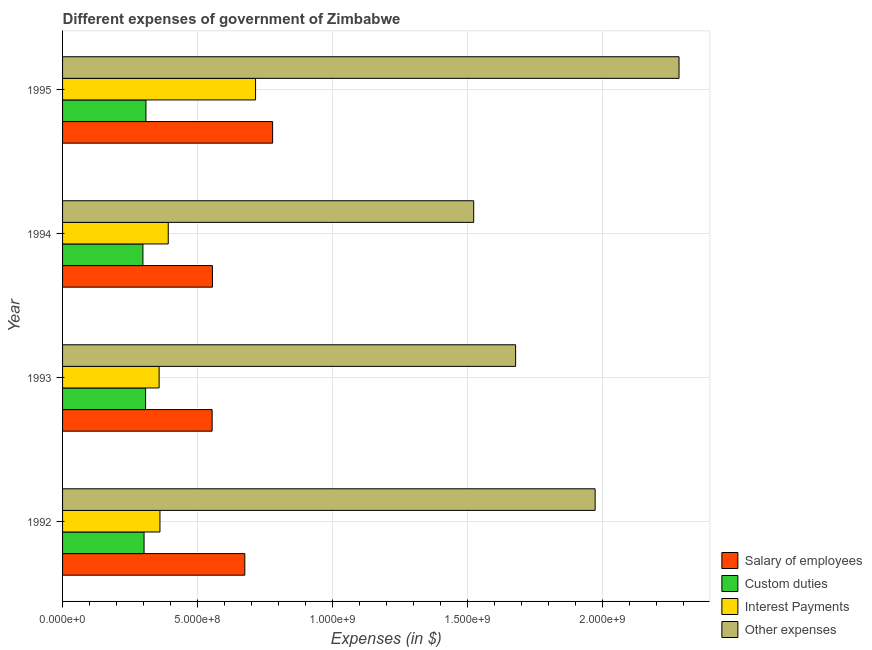Are the number of bars on each tick of the Y-axis equal?
Offer a terse response. Yes. How many bars are there on the 2nd tick from the bottom?
Make the answer very short. 4. What is the label of the 4th group of bars from the top?
Your answer should be very brief. 1992. In how many cases, is the number of bars for a given year not equal to the number of legend labels?
Keep it short and to the point. 0. What is the amount spent on salary of employees in 1994?
Your answer should be very brief. 5.55e+08. Across all years, what is the maximum amount spent on custom duties?
Make the answer very short. 3.09e+08. Across all years, what is the minimum amount spent on other expenses?
Your response must be concise. 1.52e+09. In which year was the amount spent on custom duties maximum?
Offer a very short reply. 1995. What is the total amount spent on salary of employees in the graph?
Provide a short and direct response. 2.56e+09. What is the difference between the amount spent on custom duties in 1994 and that in 1995?
Ensure brevity in your answer.  -1.12e+07. What is the difference between the amount spent on salary of employees in 1994 and the amount spent on interest payments in 1992?
Keep it short and to the point. 1.94e+08. What is the average amount spent on other expenses per year?
Provide a succinct answer. 1.86e+09. In the year 1995, what is the difference between the amount spent on interest payments and amount spent on other expenses?
Your answer should be compact. -1.57e+09. What is the ratio of the amount spent on salary of employees in 1994 to that in 1995?
Offer a terse response. 0.71. Is the amount spent on salary of employees in 1992 less than that in 1994?
Your answer should be compact. No. Is the difference between the amount spent on interest payments in 1993 and 1995 greater than the difference between the amount spent on salary of employees in 1993 and 1995?
Your answer should be very brief. No. What is the difference between the highest and the second highest amount spent on other expenses?
Your response must be concise. 3.11e+08. What is the difference between the highest and the lowest amount spent on salary of employees?
Give a very brief answer. 2.24e+08. In how many years, is the amount spent on other expenses greater than the average amount spent on other expenses taken over all years?
Offer a very short reply. 2. What does the 4th bar from the top in 1994 represents?
Your answer should be compact. Salary of employees. What does the 4th bar from the bottom in 1995 represents?
Provide a succinct answer. Other expenses. Is it the case that in every year, the sum of the amount spent on salary of employees and amount spent on custom duties is greater than the amount spent on interest payments?
Provide a short and direct response. Yes. How many bars are there?
Ensure brevity in your answer.  16. Are all the bars in the graph horizontal?
Offer a very short reply. Yes. Does the graph contain grids?
Ensure brevity in your answer.  Yes. Where does the legend appear in the graph?
Your response must be concise. Bottom right. How are the legend labels stacked?
Offer a very short reply. Vertical. What is the title of the graph?
Your answer should be compact. Different expenses of government of Zimbabwe. What is the label or title of the X-axis?
Your response must be concise. Expenses (in $). What is the label or title of the Y-axis?
Keep it short and to the point. Year. What is the Expenses (in $) of Salary of employees in 1992?
Keep it short and to the point. 6.75e+08. What is the Expenses (in $) in Custom duties in 1992?
Keep it short and to the point. 3.02e+08. What is the Expenses (in $) in Interest Payments in 1992?
Keep it short and to the point. 3.61e+08. What is the Expenses (in $) in Other expenses in 1992?
Provide a succinct answer. 1.97e+09. What is the Expenses (in $) in Salary of employees in 1993?
Give a very brief answer. 5.54e+08. What is the Expenses (in $) of Custom duties in 1993?
Your answer should be compact. 3.08e+08. What is the Expenses (in $) of Interest Payments in 1993?
Give a very brief answer. 3.58e+08. What is the Expenses (in $) in Other expenses in 1993?
Your answer should be compact. 1.68e+09. What is the Expenses (in $) in Salary of employees in 1994?
Your answer should be very brief. 5.55e+08. What is the Expenses (in $) in Custom duties in 1994?
Provide a succinct answer. 2.98e+08. What is the Expenses (in $) of Interest Payments in 1994?
Offer a terse response. 3.91e+08. What is the Expenses (in $) of Other expenses in 1994?
Ensure brevity in your answer.  1.52e+09. What is the Expenses (in $) in Salary of employees in 1995?
Your answer should be compact. 7.78e+08. What is the Expenses (in $) of Custom duties in 1995?
Your response must be concise. 3.09e+08. What is the Expenses (in $) in Interest Payments in 1995?
Keep it short and to the point. 7.15e+08. What is the Expenses (in $) of Other expenses in 1995?
Give a very brief answer. 2.28e+09. Across all years, what is the maximum Expenses (in $) in Salary of employees?
Give a very brief answer. 7.78e+08. Across all years, what is the maximum Expenses (in $) of Custom duties?
Give a very brief answer. 3.09e+08. Across all years, what is the maximum Expenses (in $) of Interest Payments?
Make the answer very short. 7.15e+08. Across all years, what is the maximum Expenses (in $) of Other expenses?
Keep it short and to the point. 2.28e+09. Across all years, what is the minimum Expenses (in $) of Salary of employees?
Make the answer very short. 5.54e+08. Across all years, what is the minimum Expenses (in $) in Custom duties?
Your response must be concise. 2.98e+08. Across all years, what is the minimum Expenses (in $) in Interest Payments?
Keep it short and to the point. 3.58e+08. Across all years, what is the minimum Expenses (in $) in Other expenses?
Provide a succinct answer. 1.52e+09. What is the total Expenses (in $) in Salary of employees in the graph?
Ensure brevity in your answer.  2.56e+09. What is the total Expenses (in $) of Custom duties in the graph?
Provide a succinct answer. 1.22e+09. What is the total Expenses (in $) in Interest Payments in the graph?
Make the answer very short. 1.82e+09. What is the total Expenses (in $) in Other expenses in the graph?
Your answer should be compact. 7.46e+09. What is the difference between the Expenses (in $) of Salary of employees in 1992 and that in 1993?
Keep it short and to the point. 1.21e+08. What is the difference between the Expenses (in $) of Custom duties in 1992 and that in 1993?
Your answer should be compact. -5.70e+06. What is the difference between the Expenses (in $) of Interest Payments in 1992 and that in 1993?
Your answer should be very brief. 3.08e+06. What is the difference between the Expenses (in $) in Other expenses in 1992 and that in 1993?
Your answer should be very brief. 2.94e+08. What is the difference between the Expenses (in $) in Salary of employees in 1992 and that in 1994?
Offer a terse response. 1.20e+08. What is the difference between the Expenses (in $) in Custom duties in 1992 and that in 1994?
Provide a short and direct response. 4.22e+06. What is the difference between the Expenses (in $) in Interest Payments in 1992 and that in 1994?
Provide a short and direct response. -3.08e+07. What is the difference between the Expenses (in $) in Other expenses in 1992 and that in 1994?
Make the answer very short. 4.50e+08. What is the difference between the Expenses (in $) in Salary of employees in 1992 and that in 1995?
Make the answer very short. -1.03e+08. What is the difference between the Expenses (in $) of Custom duties in 1992 and that in 1995?
Your response must be concise. -6.99e+06. What is the difference between the Expenses (in $) in Interest Payments in 1992 and that in 1995?
Your answer should be compact. -3.54e+08. What is the difference between the Expenses (in $) in Other expenses in 1992 and that in 1995?
Your answer should be very brief. -3.11e+08. What is the difference between the Expenses (in $) of Salary of employees in 1993 and that in 1994?
Provide a short and direct response. -1.19e+06. What is the difference between the Expenses (in $) in Custom duties in 1993 and that in 1994?
Offer a very short reply. 9.93e+06. What is the difference between the Expenses (in $) of Interest Payments in 1993 and that in 1994?
Keep it short and to the point. -3.39e+07. What is the difference between the Expenses (in $) of Other expenses in 1993 and that in 1994?
Your response must be concise. 1.55e+08. What is the difference between the Expenses (in $) in Salary of employees in 1993 and that in 1995?
Provide a succinct answer. -2.24e+08. What is the difference between the Expenses (in $) in Custom duties in 1993 and that in 1995?
Your answer should be very brief. -1.28e+06. What is the difference between the Expenses (in $) in Interest Payments in 1993 and that in 1995?
Provide a short and direct response. -3.57e+08. What is the difference between the Expenses (in $) of Other expenses in 1993 and that in 1995?
Offer a terse response. -6.05e+08. What is the difference between the Expenses (in $) of Salary of employees in 1994 and that in 1995?
Offer a very short reply. -2.23e+08. What is the difference between the Expenses (in $) in Custom duties in 1994 and that in 1995?
Your answer should be very brief. -1.12e+07. What is the difference between the Expenses (in $) of Interest Payments in 1994 and that in 1995?
Offer a terse response. -3.23e+08. What is the difference between the Expenses (in $) of Other expenses in 1994 and that in 1995?
Offer a very short reply. -7.60e+08. What is the difference between the Expenses (in $) of Salary of employees in 1992 and the Expenses (in $) of Custom duties in 1993?
Your answer should be compact. 3.67e+08. What is the difference between the Expenses (in $) of Salary of employees in 1992 and the Expenses (in $) of Interest Payments in 1993?
Ensure brevity in your answer.  3.17e+08. What is the difference between the Expenses (in $) of Salary of employees in 1992 and the Expenses (in $) of Other expenses in 1993?
Offer a very short reply. -1.00e+09. What is the difference between the Expenses (in $) in Custom duties in 1992 and the Expenses (in $) in Interest Payments in 1993?
Make the answer very short. -5.57e+07. What is the difference between the Expenses (in $) of Custom duties in 1992 and the Expenses (in $) of Other expenses in 1993?
Provide a short and direct response. -1.38e+09. What is the difference between the Expenses (in $) in Interest Payments in 1992 and the Expenses (in $) in Other expenses in 1993?
Give a very brief answer. -1.32e+09. What is the difference between the Expenses (in $) of Salary of employees in 1992 and the Expenses (in $) of Custom duties in 1994?
Ensure brevity in your answer.  3.77e+08. What is the difference between the Expenses (in $) in Salary of employees in 1992 and the Expenses (in $) in Interest Payments in 1994?
Make the answer very short. 2.84e+08. What is the difference between the Expenses (in $) in Salary of employees in 1992 and the Expenses (in $) in Other expenses in 1994?
Keep it short and to the point. -8.48e+08. What is the difference between the Expenses (in $) in Custom duties in 1992 and the Expenses (in $) in Interest Payments in 1994?
Provide a short and direct response. -8.96e+07. What is the difference between the Expenses (in $) in Custom duties in 1992 and the Expenses (in $) in Other expenses in 1994?
Offer a very short reply. -1.22e+09. What is the difference between the Expenses (in $) in Interest Payments in 1992 and the Expenses (in $) in Other expenses in 1994?
Offer a terse response. -1.16e+09. What is the difference between the Expenses (in $) in Salary of employees in 1992 and the Expenses (in $) in Custom duties in 1995?
Keep it short and to the point. 3.66e+08. What is the difference between the Expenses (in $) in Salary of employees in 1992 and the Expenses (in $) in Interest Payments in 1995?
Ensure brevity in your answer.  -3.98e+07. What is the difference between the Expenses (in $) of Salary of employees in 1992 and the Expenses (in $) of Other expenses in 1995?
Your response must be concise. -1.61e+09. What is the difference between the Expenses (in $) of Custom duties in 1992 and the Expenses (in $) of Interest Payments in 1995?
Ensure brevity in your answer.  -4.13e+08. What is the difference between the Expenses (in $) in Custom duties in 1992 and the Expenses (in $) in Other expenses in 1995?
Offer a very short reply. -1.98e+09. What is the difference between the Expenses (in $) of Interest Payments in 1992 and the Expenses (in $) of Other expenses in 1995?
Offer a terse response. -1.92e+09. What is the difference between the Expenses (in $) in Salary of employees in 1993 and the Expenses (in $) in Custom duties in 1994?
Your answer should be compact. 2.56e+08. What is the difference between the Expenses (in $) of Salary of employees in 1993 and the Expenses (in $) of Interest Payments in 1994?
Make the answer very short. 1.63e+08. What is the difference between the Expenses (in $) in Salary of employees in 1993 and the Expenses (in $) in Other expenses in 1994?
Ensure brevity in your answer.  -9.69e+08. What is the difference between the Expenses (in $) in Custom duties in 1993 and the Expenses (in $) in Interest Payments in 1994?
Ensure brevity in your answer.  -8.39e+07. What is the difference between the Expenses (in $) of Custom duties in 1993 and the Expenses (in $) of Other expenses in 1994?
Make the answer very short. -1.22e+09. What is the difference between the Expenses (in $) of Interest Payments in 1993 and the Expenses (in $) of Other expenses in 1994?
Offer a terse response. -1.17e+09. What is the difference between the Expenses (in $) in Salary of employees in 1993 and the Expenses (in $) in Custom duties in 1995?
Your response must be concise. 2.45e+08. What is the difference between the Expenses (in $) in Salary of employees in 1993 and the Expenses (in $) in Interest Payments in 1995?
Make the answer very short. -1.61e+08. What is the difference between the Expenses (in $) of Salary of employees in 1993 and the Expenses (in $) of Other expenses in 1995?
Ensure brevity in your answer.  -1.73e+09. What is the difference between the Expenses (in $) in Custom duties in 1993 and the Expenses (in $) in Interest Payments in 1995?
Your answer should be compact. -4.07e+08. What is the difference between the Expenses (in $) in Custom duties in 1993 and the Expenses (in $) in Other expenses in 1995?
Provide a short and direct response. -1.98e+09. What is the difference between the Expenses (in $) of Interest Payments in 1993 and the Expenses (in $) of Other expenses in 1995?
Give a very brief answer. -1.93e+09. What is the difference between the Expenses (in $) of Salary of employees in 1994 and the Expenses (in $) of Custom duties in 1995?
Your answer should be very brief. 2.46e+08. What is the difference between the Expenses (in $) of Salary of employees in 1994 and the Expenses (in $) of Interest Payments in 1995?
Provide a succinct answer. -1.60e+08. What is the difference between the Expenses (in $) of Salary of employees in 1994 and the Expenses (in $) of Other expenses in 1995?
Keep it short and to the point. -1.73e+09. What is the difference between the Expenses (in $) of Custom duties in 1994 and the Expenses (in $) of Interest Payments in 1995?
Give a very brief answer. -4.17e+08. What is the difference between the Expenses (in $) of Custom duties in 1994 and the Expenses (in $) of Other expenses in 1995?
Keep it short and to the point. -1.99e+09. What is the difference between the Expenses (in $) in Interest Payments in 1994 and the Expenses (in $) in Other expenses in 1995?
Give a very brief answer. -1.89e+09. What is the average Expenses (in $) in Salary of employees per year?
Offer a terse response. 6.40e+08. What is the average Expenses (in $) in Custom duties per year?
Your answer should be compact. 3.04e+08. What is the average Expenses (in $) in Interest Payments per year?
Your answer should be very brief. 4.56e+08. What is the average Expenses (in $) of Other expenses per year?
Provide a succinct answer. 1.86e+09. In the year 1992, what is the difference between the Expenses (in $) in Salary of employees and Expenses (in $) in Custom duties?
Keep it short and to the point. 3.73e+08. In the year 1992, what is the difference between the Expenses (in $) of Salary of employees and Expenses (in $) of Interest Payments?
Provide a short and direct response. 3.14e+08. In the year 1992, what is the difference between the Expenses (in $) of Salary of employees and Expenses (in $) of Other expenses?
Your answer should be very brief. -1.30e+09. In the year 1992, what is the difference between the Expenses (in $) of Custom duties and Expenses (in $) of Interest Payments?
Your answer should be very brief. -5.88e+07. In the year 1992, what is the difference between the Expenses (in $) of Custom duties and Expenses (in $) of Other expenses?
Provide a short and direct response. -1.67e+09. In the year 1992, what is the difference between the Expenses (in $) of Interest Payments and Expenses (in $) of Other expenses?
Offer a terse response. -1.61e+09. In the year 1993, what is the difference between the Expenses (in $) of Salary of employees and Expenses (in $) of Custom duties?
Provide a succinct answer. 2.46e+08. In the year 1993, what is the difference between the Expenses (in $) in Salary of employees and Expenses (in $) in Interest Payments?
Keep it short and to the point. 1.96e+08. In the year 1993, what is the difference between the Expenses (in $) in Salary of employees and Expenses (in $) in Other expenses?
Make the answer very short. -1.12e+09. In the year 1993, what is the difference between the Expenses (in $) of Custom duties and Expenses (in $) of Interest Payments?
Provide a short and direct response. -5.00e+07. In the year 1993, what is the difference between the Expenses (in $) in Custom duties and Expenses (in $) in Other expenses?
Provide a succinct answer. -1.37e+09. In the year 1993, what is the difference between the Expenses (in $) of Interest Payments and Expenses (in $) of Other expenses?
Ensure brevity in your answer.  -1.32e+09. In the year 1994, what is the difference between the Expenses (in $) of Salary of employees and Expenses (in $) of Custom duties?
Offer a very short reply. 2.58e+08. In the year 1994, what is the difference between the Expenses (in $) in Salary of employees and Expenses (in $) in Interest Payments?
Keep it short and to the point. 1.64e+08. In the year 1994, what is the difference between the Expenses (in $) in Salary of employees and Expenses (in $) in Other expenses?
Your response must be concise. -9.67e+08. In the year 1994, what is the difference between the Expenses (in $) of Custom duties and Expenses (in $) of Interest Payments?
Your response must be concise. -9.38e+07. In the year 1994, what is the difference between the Expenses (in $) of Custom duties and Expenses (in $) of Other expenses?
Offer a very short reply. -1.23e+09. In the year 1994, what is the difference between the Expenses (in $) of Interest Payments and Expenses (in $) of Other expenses?
Offer a very short reply. -1.13e+09. In the year 1995, what is the difference between the Expenses (in $) of Salary of employees and Expenses (in $) of Custom duties?
Offer a terse response. 4.69e+08. In the year 1995, what is the difference between the Expenses (in $) in Salary of employees and Expenses (in $) in Interest Payments?
Make the answer very short. 6.31e+07. In the year 1995, what is the difference between the Expenses (in $) in Salary of employees and Expenses (in $) in Other expenses?
Ensure brevity in your answer.  -1.51e+09. In the year 1995, what is the difference between the Expenses (in $) of Custom duties and Expenses (in $) of Interest Payments?
Provide a succinct answer. -4.06e+08. In the year 1995, what is the difference between the Expenses (in $) of Custom duties and Expenses (in $) of Other expenses?
Give a very brief answer. -1.97e+09. In the year 1995, what is the difference between the Expenses (in $) in Interest Payments and Expenses (in $) in Other expenses?
Offer a very short reply. -1.57e+09. What is the ratio of the Expenses (in $) in Salary of employees in 1992 to that in 1993?
Make the answer very short. 1.22. What is the ratio of the Expenses (in $) of Custom duties in 1992 to that in 1993?
Offer a very short reply. 0.98. What is the ratio of the Expenses (in $) of Interest Payments in 1992 to that in 1993?
Your answer should be very brief. 1.01. What is the ratio of the Expenses (in $) of Other expenses in 1992 to that in 1993?
Keep it short and to the point. 1.18. What is the ratio of the Expenses (in $) in Salary of employees in 1992 to that in 1994?
Offer a very short reply. 1.22. What is the ratio of the Expenses (in $) in Custom duties in 1992 to that in 1994?
Your response must be concise. 1.01. What is the ratio of the Expenses (in $) in Interest Payments in 1992 to that in 1994?
Provide a short and direct response. 0.92. What is the ratio of the Expenses (in $) of Other expenses in 1992 to that in 1994?
Provide a succinct answer. 1.3. What is the ratio of the Expenses (in $) in Salary of employees in 1992 to that in 1995?
Give a very brief answer. 0.87. What is the ratio of the Expenses (in $) in Custom duties in 1992 to that in 1995?
Provide a succinct answer. 0.98. What is the ratio of the Expenses (in $) of Interest Payments in 1992 to that in 1995?
Make the answer very short. 0.5. What is the ratio of the Expenses (in $) of Other expenses in 1992 to that in 1995?
Your answer should be compact. 0.86. What is the ratio of the Expenses (in $) of Custom duties in 1993 to that in 1994?
Provide a short and direct response. 1.03. What is the ratio of the Expenses (in $) of Interest Payments in 1993 to that in 1994?
Your response must be concise. 0.91. What is the ratio of the Expenses (in $) in Other expenses in 1993 to that in 1994?
Your answer should be compact. 1.1. What is the ratio of the Expenses (in $) in Salary of employees in 1993 to that in 1995?
Keep it short and to the point. 0.71. What is the ratio of the Expenses (in $) of Interest Payments in 1993 to that in 1995?
Give a very brief answer. 0.5. What is the ratio of the Expenses (in $) in Other expenses in 1993 to that in 1995?
Make the answer very short. 0.73. What is the ratio of the Expenses (in $) in Salary of employees in 1994 to that in 1995?
Give a very brief answer. 0.71. What is the ratio of the Expenses (in $) in Custom duties in 1994 to that in 1995?
Keep it short and to the point. 0.96. What is the ratio of the Expenses (in $) in Interest Payments in 1994 to that in 1995?
Make the answer very short. 0.55. What is the ratio of the Expenses (in $) in Other expenses in 1994 to that in 1995?
Keep it short and to the point. 0.67. What is the difference between the highest and the second highest Expenses (in $) of Salary of employees?
Give a very brief answer. 1.03e+08. What is the difference between the highest and the second highest Expenses (in $) of Custom duties?
Your answer should be very brief. 1.28e+06. What is the difference between the highest and the second highest Expenses (in $) in Interest Payments?
Give a very brief answer. 3.23e+08. What is the difference between the highest and the second highest Expenses (in $) in Other expenses?
Your answer should be compact. 3.11e+08. What is the difference between the highest and the lowest Expenses (in $) of Salary of employees?
Make the answer very short. 2.24e+08. What is the difference between the highest and the lowest Expenses (in $) in Custom duties?
Your response must be concise. 1.12e+07. What is the difference between the highest and the lowest Expenses (in $) of Interest Payments?
Your response must be concise. 3.57e+08. What is the difference between the highest and the lowest Expenses (in $) of Other expenses?
Your answer should be very brief. 7.60e+08. 